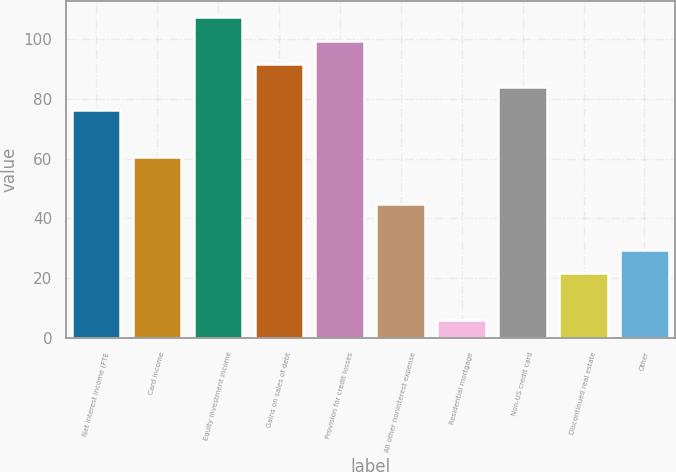Convert chart. <chart><loc_0><loc_0><loc_500><loc_500><bar_chart><fcel>Net interest income (FTE<fcel>Card income<fcel>Equity investment income<fcel>Gains on sales of debt<fcel>Provision for credit losses<fcel>All other noninterest expense<fcel>Residential mortgage<fcel>Non-US credit card<fcel>Discontinued real estate<fcel>Other<nl><fcel>76.2<fcel>60.6<fcel>107.4<fcel>91.8<fcel>99.6<fcel>45<fcel>6<fcel>84<fcel>21.6<fcel>29.4<nl></chart> 